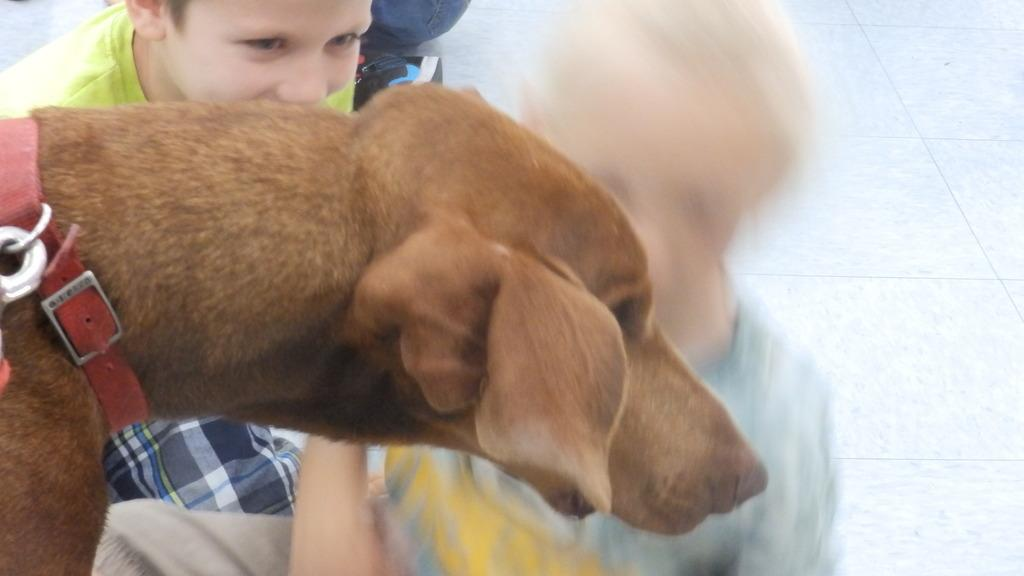What type of animal is in the image? There is a brown color dog in the image. Who else is present in the image besides the dog? There are people visible in the image. How are the people dressed in the image? The people are wearing different dresses. What is the color of the surface in the image? There is a white surface in the image. Can you tell me how many times the dog bit the people in the image? There is no indication in the image that the dog has bitten anyone, so it cannot be determined from the picture. 